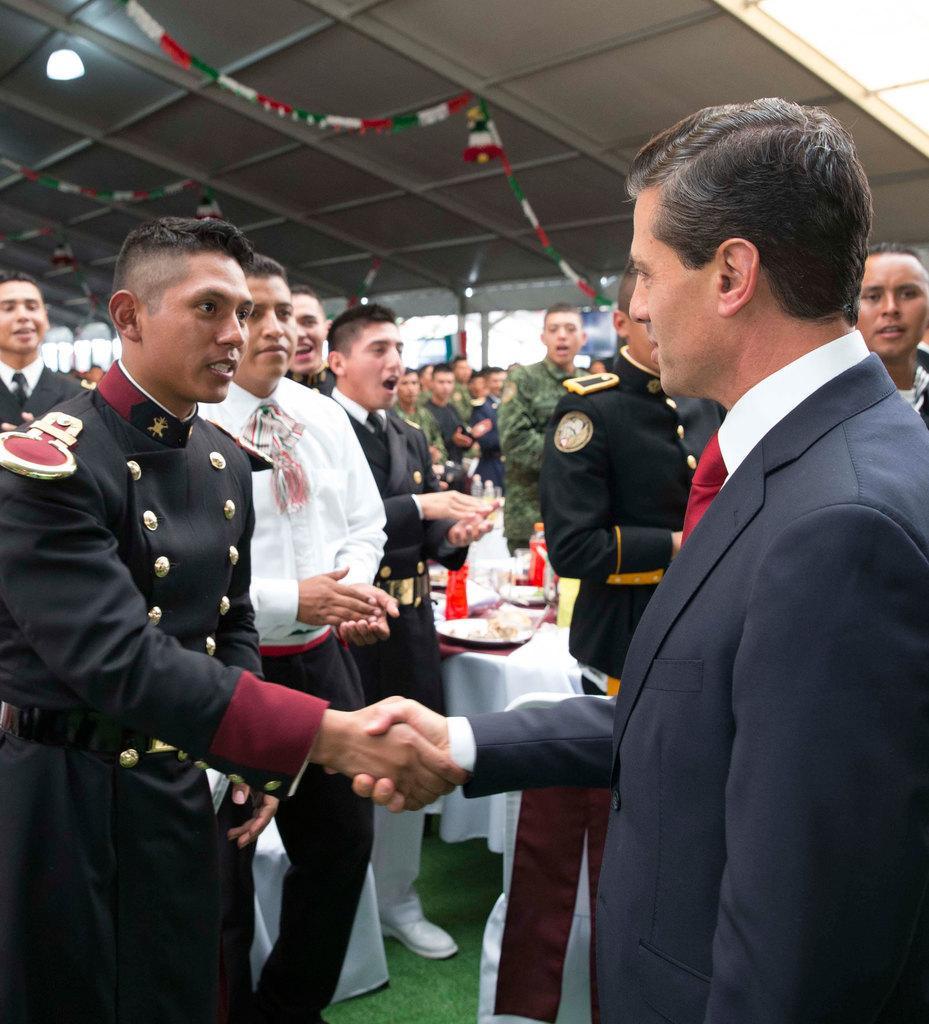How would you summarize this image in a sentence or two? In this picture we can see two people shaking their hands. There are few people in the background. We can see bottles and plates on the table. There is a light and some decorative items on top. 